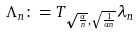Convert formula to latex. <formula><loc_0><loc_0><loc_500><loc_500>\Lambda _ { n } \colon = T _ { \sqrt { \frac { \alpha } { n } } , \sqrt { \frac { 1 } { \alpha n } } } \lambda _ { n }</formula> 